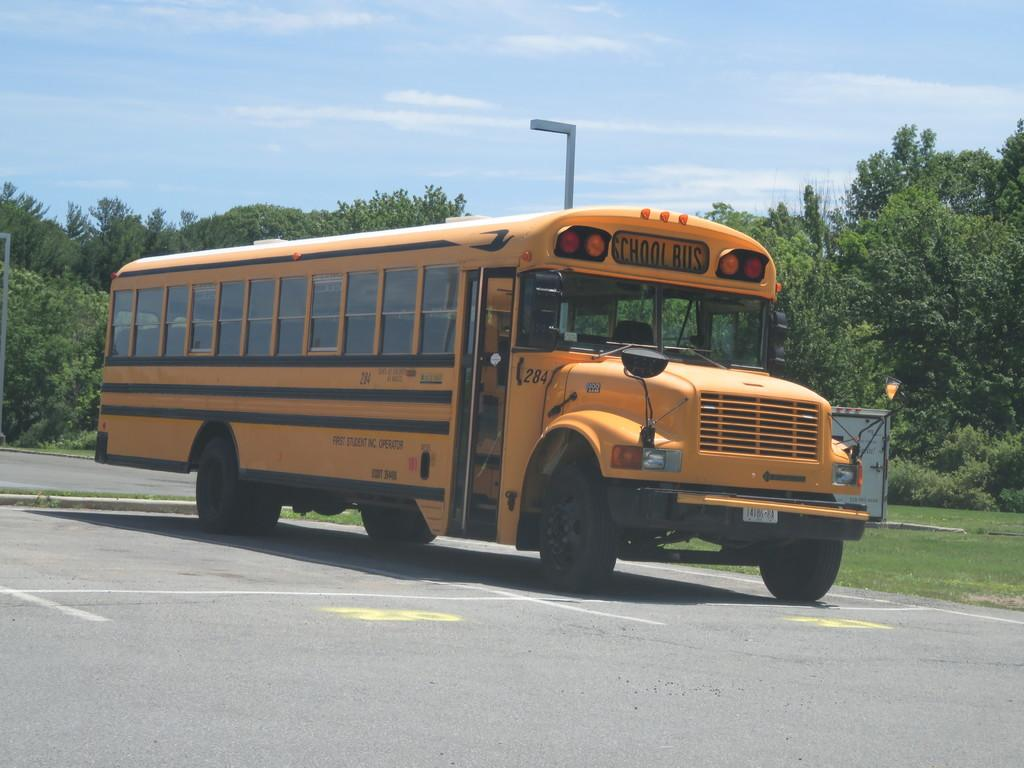What is on the road in the image? There is a vehicle on the road in the image. What can be seen beside the road in the image? There are trees beside the road in the image. What type of vegetation is visible in the image? There is grass visible in the image. What type of cap is being worn by the basin in the image? There is no cap or basin present in the image; it features a vehicle on the road and trees beside the road. 